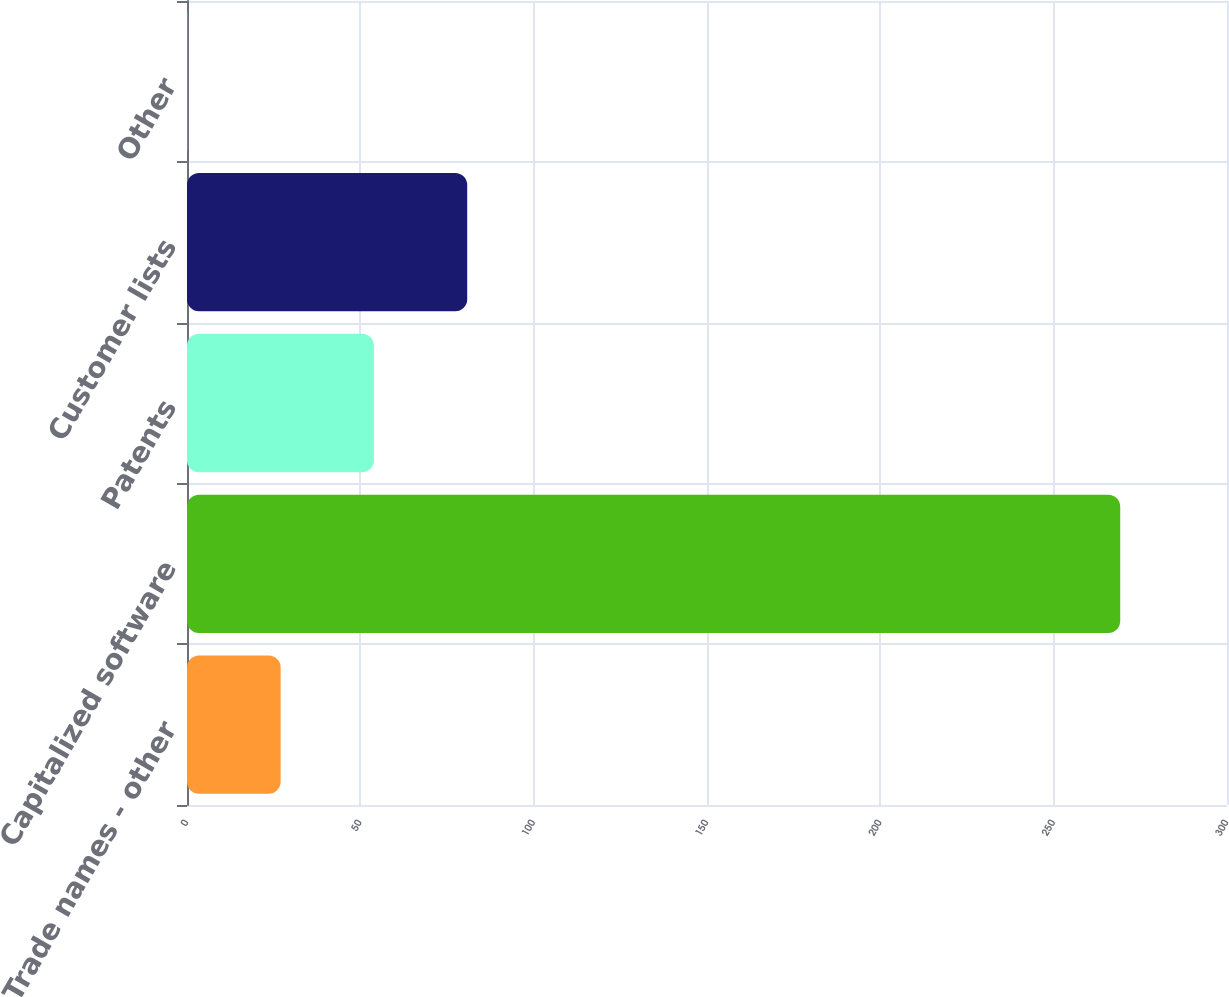Convert chart to OTSL. <chart><loc_0><loc_0><loc_500><loc_500><bar_chart><fcel>Trade names - other<fcel>Capitalized software<fcel>Patents<fcel>Customer lists<fcel>Other<nl><fcel>27.01<fcel>269.2<fcel>53.92<fcel>80.83<fcel>0.1<nl></chart> 